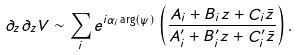Convert formula to latex. <formula><loc_0><loc_0><loc_500><loc_500>\partial _ { z } \partial _ { z } V \sim \sum _ { i } e ^ { i \alpha _ { i } \arg ( \psi ) } \left ( \frac { A _ { i } + B _ { i } z + C _ { i } { \bar { z } } } { A ^ { \prime } _ { i } + B ^ { \prime } _ { i } z + C ^ { \prime } _ { i } { \bar { z } } } \right ) .</formula> 